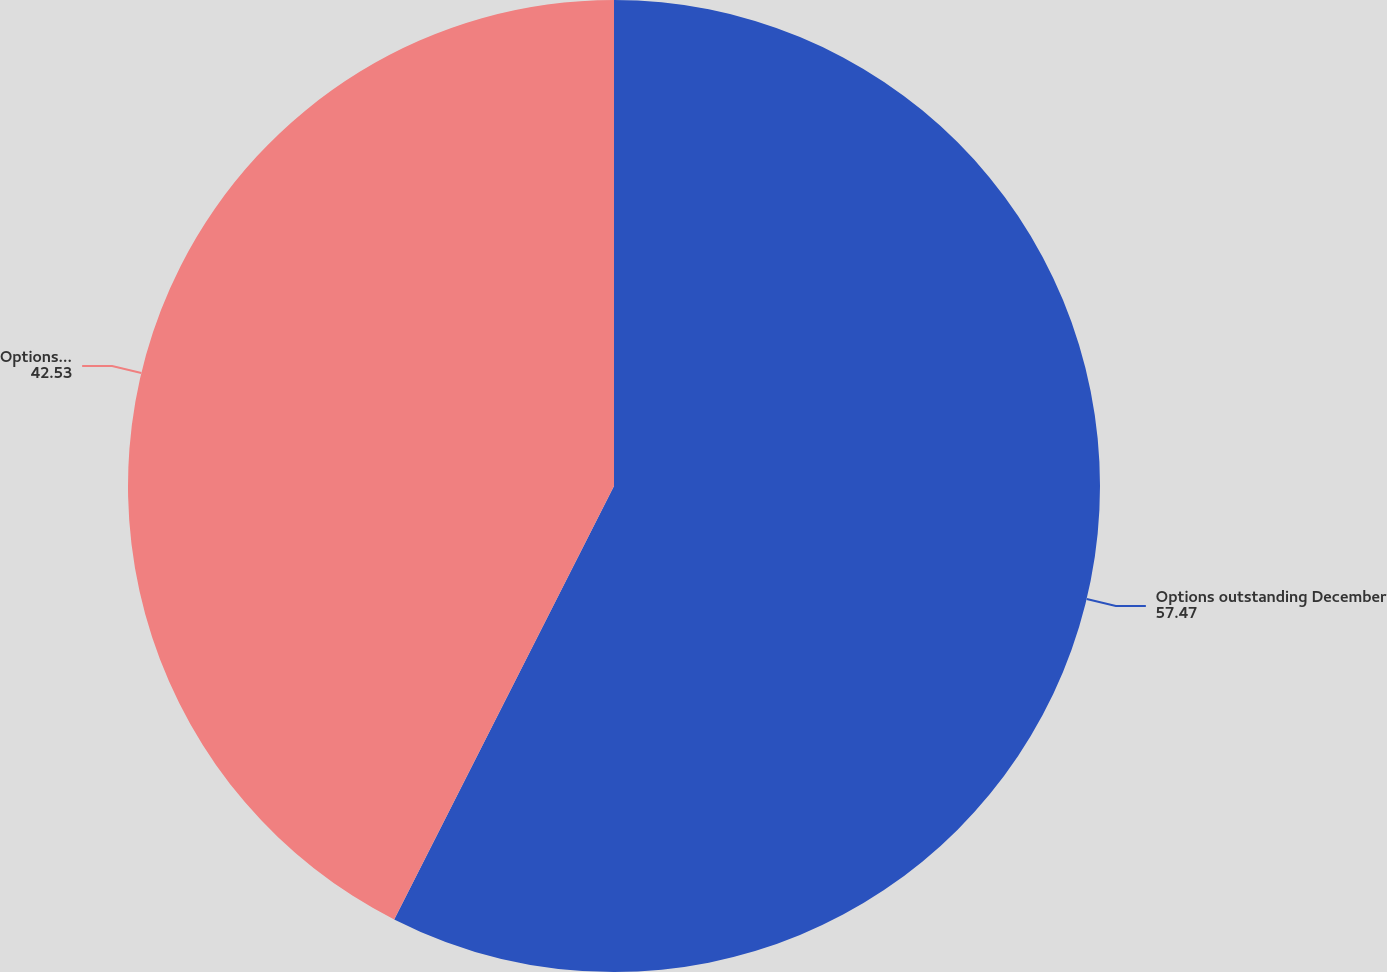Convert chart. <chart><loc_0><loc_0><loc_500><loc_500><pie_chart><fcel>Options outstanding December<fcel>Options exercisable December<nl><fcel>57.47%<fcel>42.53%<nl></chart> 